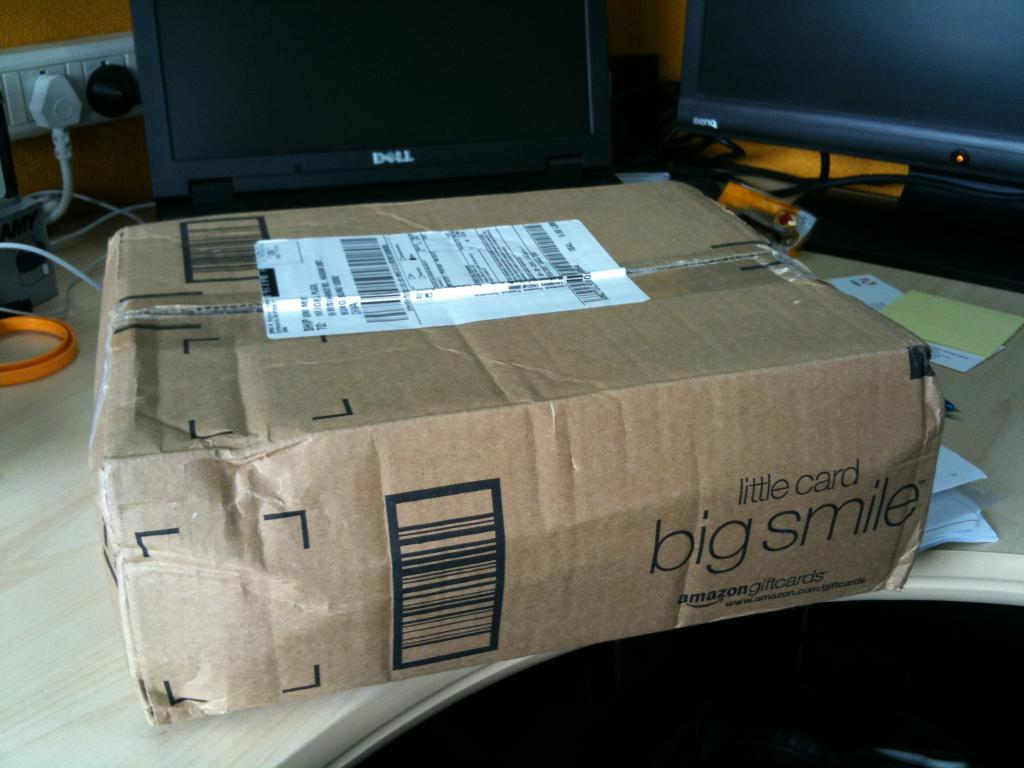<image>
Describe the image concisely. A brown box with the words Amazon little card big smile on it 